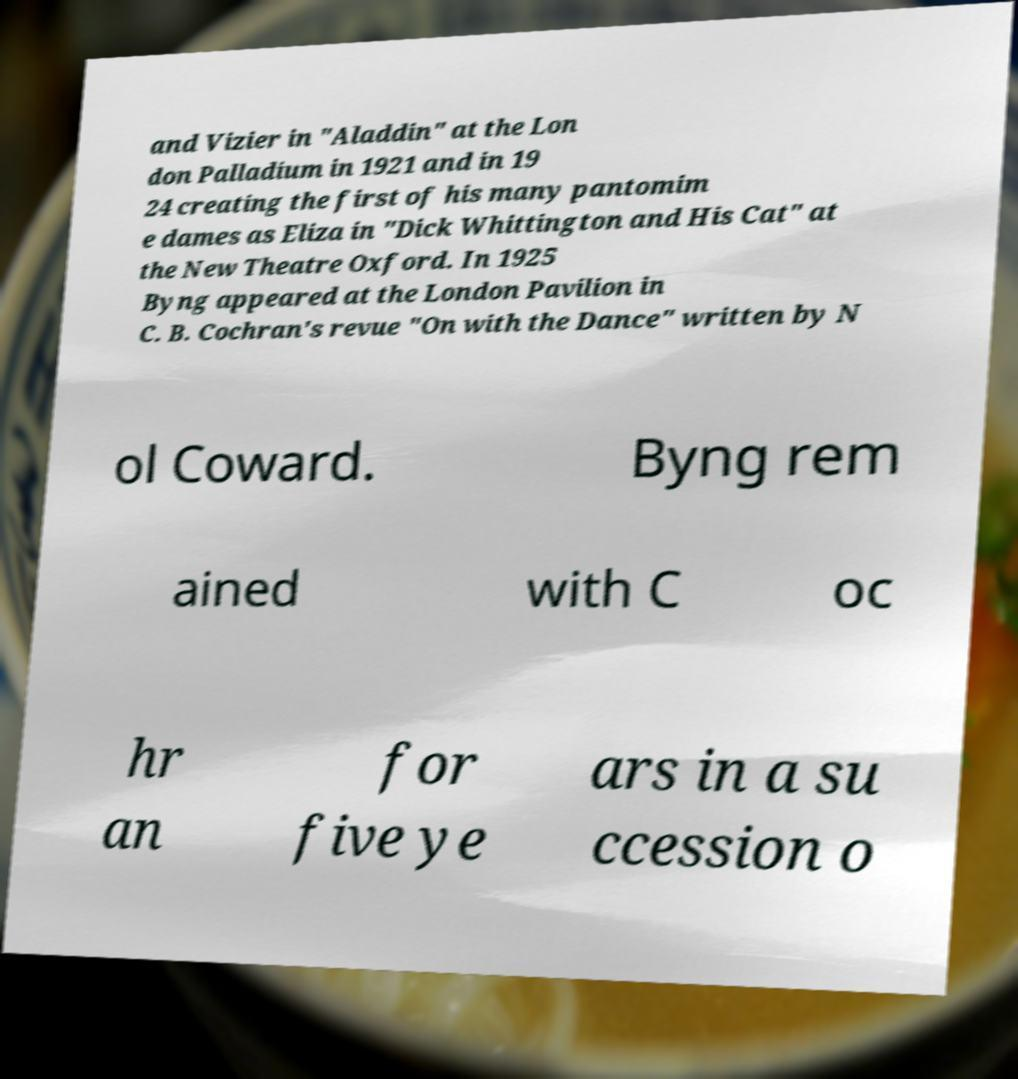For documentation purposes, I need the text within this image transcribed. Could you provide that? and Vizier in "Aladdin" at the Lon don Palladium in 1921 and in 19 24 creating the first of his many pantomim e dames as Eliza in "Dick Whittington and His Cat" at the New Theatre Oxford. In 1925 Byng appeared at the London Pavilion in C. B. Cochran's revue "On with the Dance" written by N ol Coward. Byng rem ained with C oc hr an for five ye ars in a su ccession o 